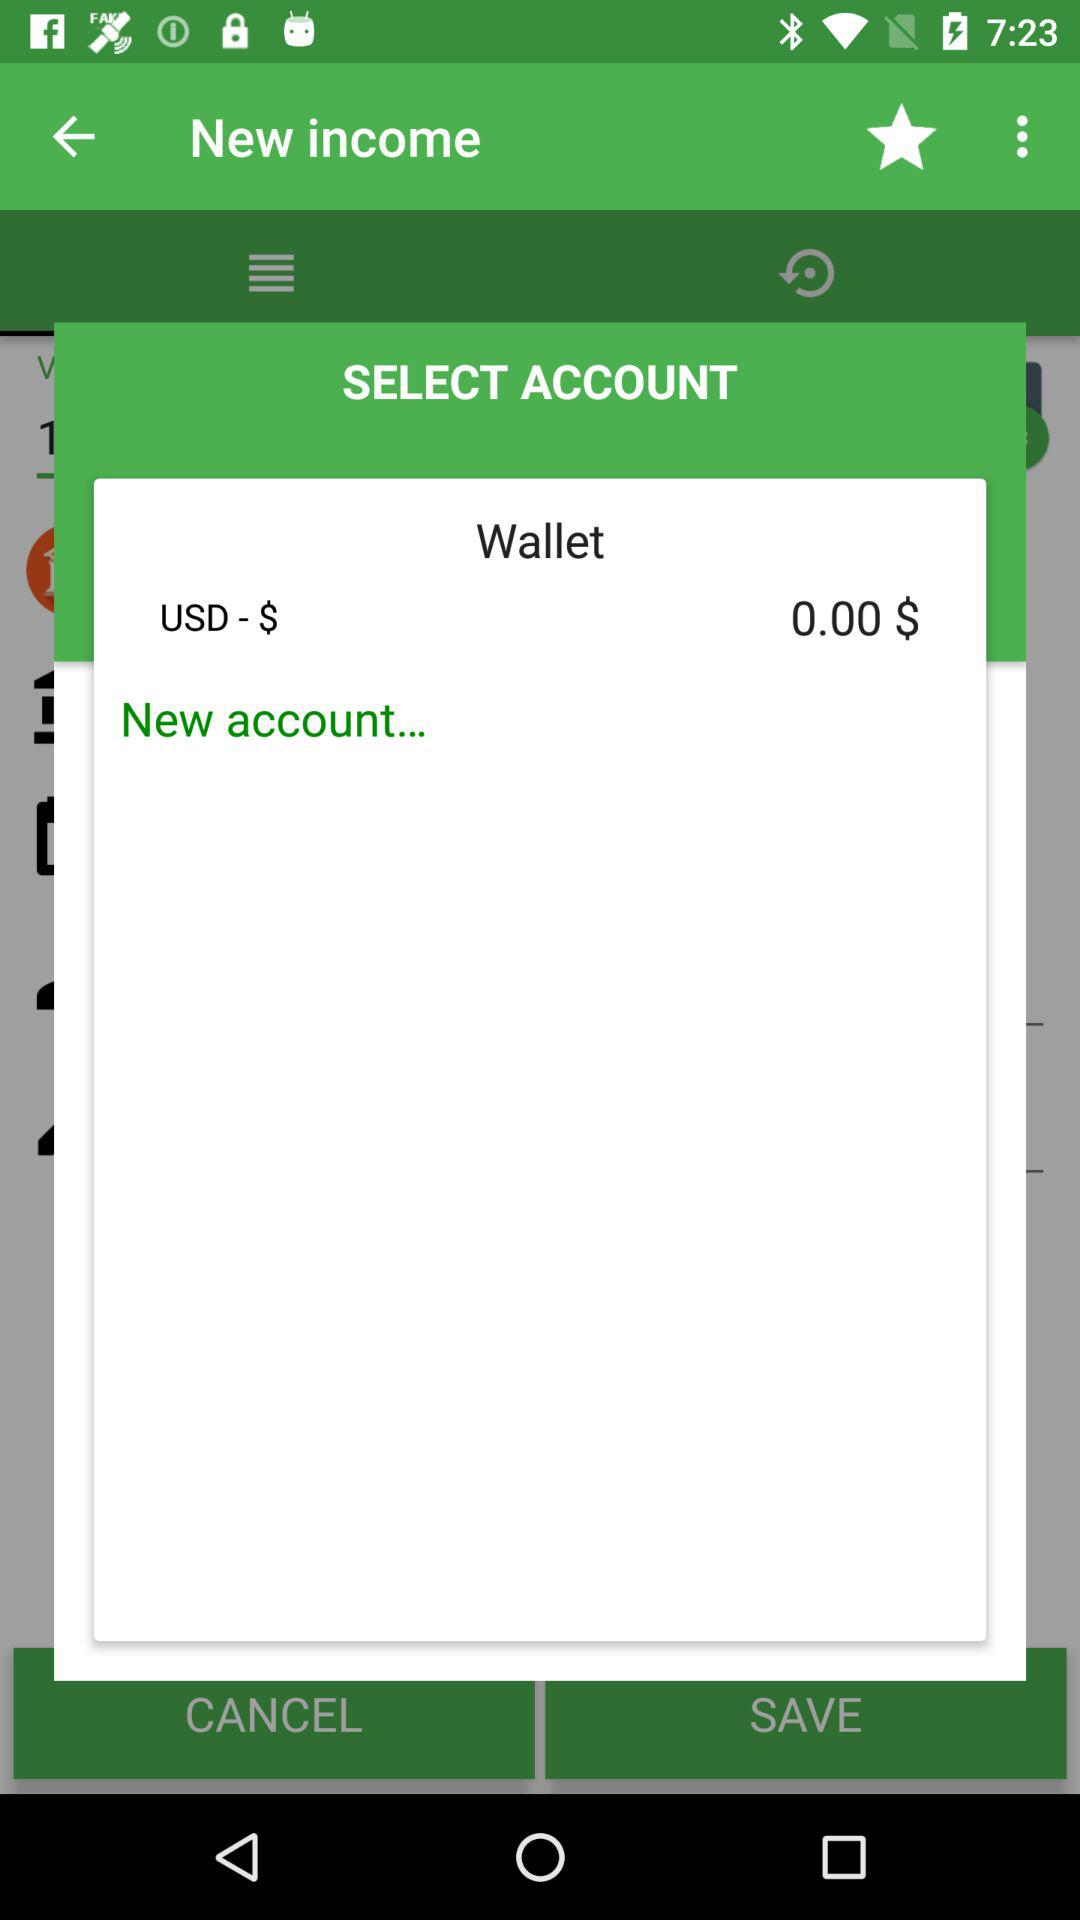How much money is in the wallet?
Answer the question using a single word or phrase. 0.00 $ 